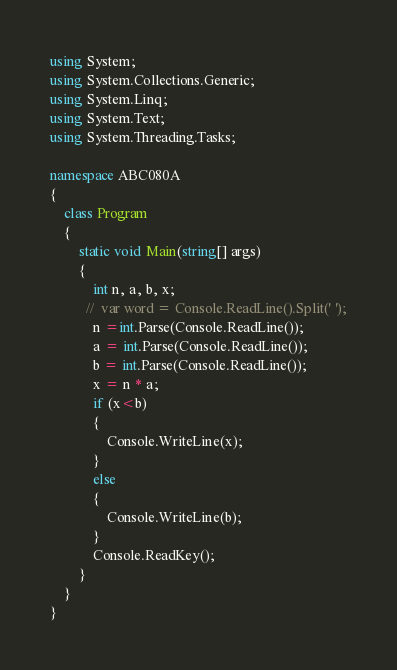<code> <loc_0><loc_0><loc_500><loc_500><_C#_>using System;
using System.Collections.Generic;
using System.Linq;
using System.Text;
using System.Threading.Tasks;

namespace ABC080A
{
    class Program
    {
        static void Main(string[] args)
        {
            int n, a, b, x;
          //  var word = Console.ReadLine().Split(' ');
            n =int.Parse(Console.ReadLine());
            a = int.Parse(Console.ReadLine());
            b = int.Parse(Console.ReadLine());
            x = n * a;
            if (x<b)
            {
                Console.WriteLine(x);
            }
            else
            {
                Console.WriteLine(b);
            }
            Console.ReadKey();
        }
    }
}
</code> 